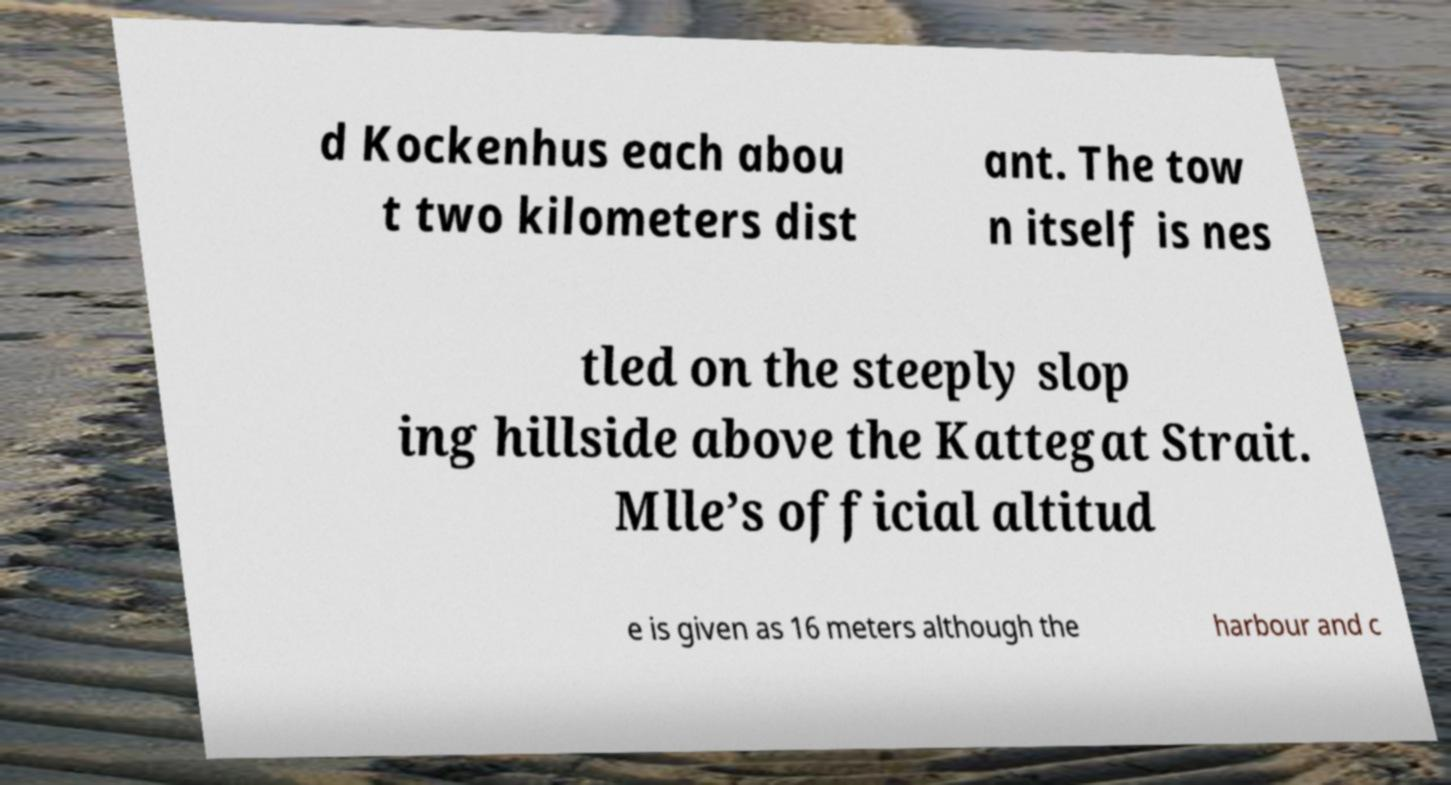Please identify and transcribe the text found in this image. d Kockenhus each abou t two kilometers dist ant. The tow n itself is nes tled on the steeply slop ing hillside above the Kattegat Strait. Mlle’s official altitud e is given as 16 meters although the harbour and c 